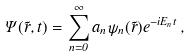<formula> <loc_0><loc_0><loc_500><loc_500>\Psi ( \vec { r } , t ) = \sum _ { n = 0 } ^ { \infty } { a _ { n } \psi _ { n } ( \vec { r } ) e ^ { - i E _ { n } t } } \, ,</formula> 